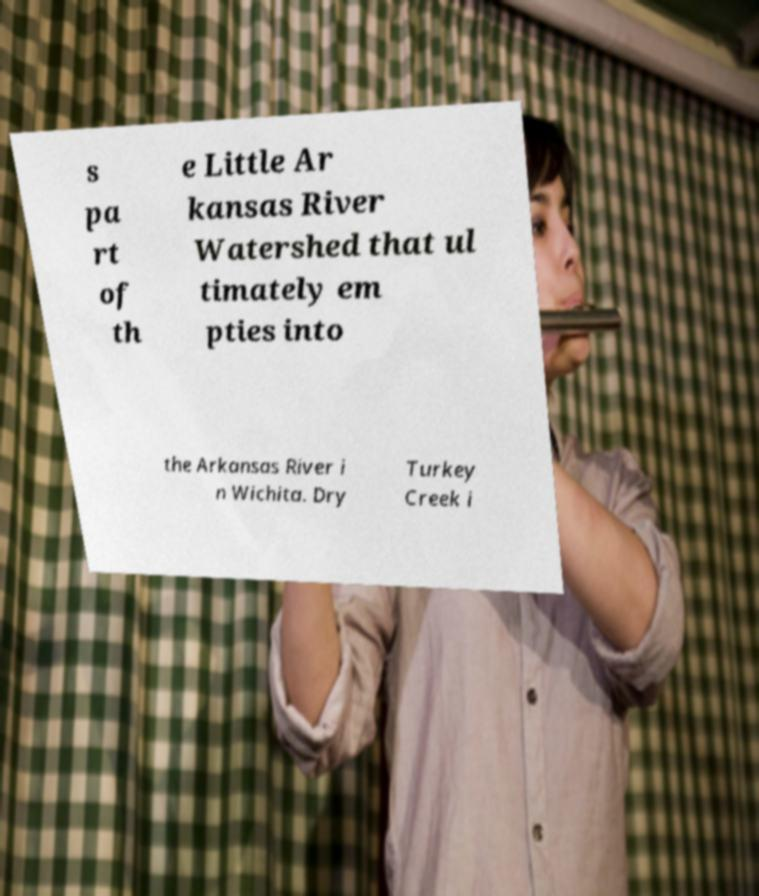Please read and relay the text visible in this image. What does it say? s pa rt of th e Little Ar kansas River Watershed that ul timately em pties into the Arkansas River i n Wichita. Dry Turkey Creek i 